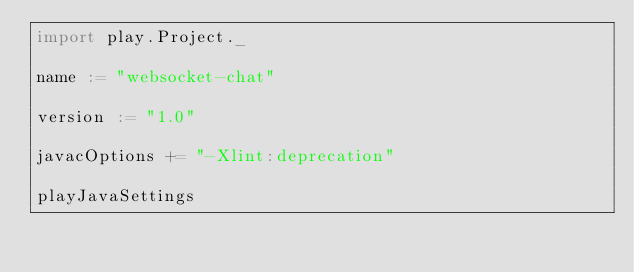<code> <loc_0><loc_0><loc_500><loc_500><_Scala_>import play.Project._

name := "websocket-chat"

version := "1.0"

javacOptions += "-Xlint:deprecation"     

playJavaSettings
</code> 